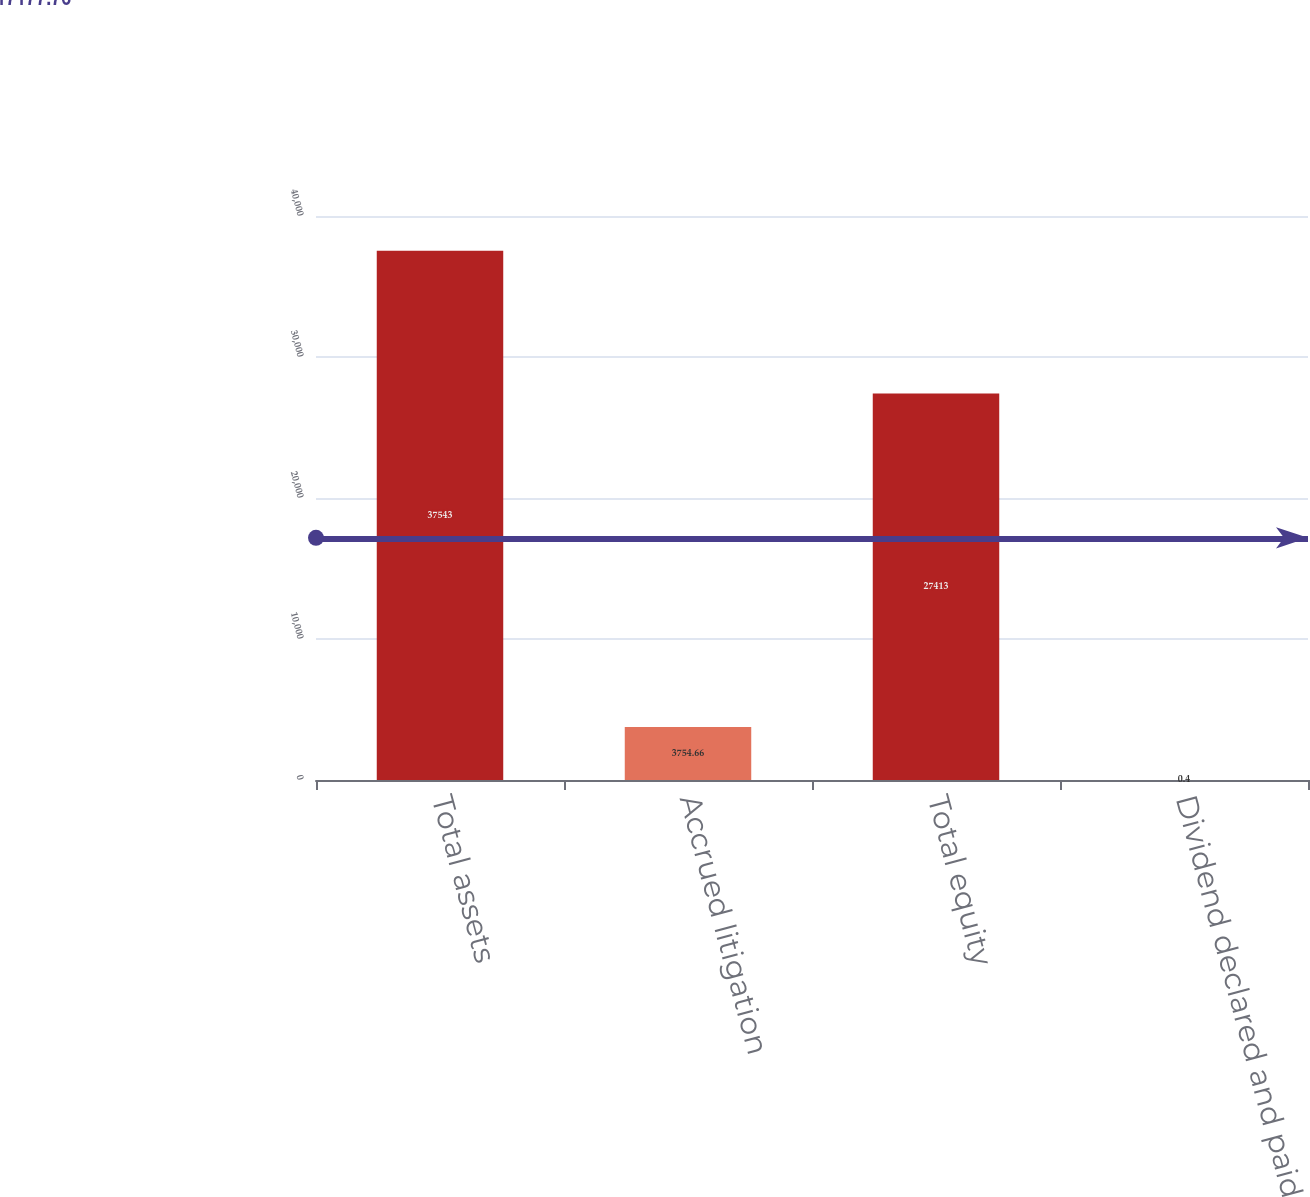Convert chart to OTSL. <chart><loc_0><loc_0><loc_500><loc_500><bar_chart><fcel>Total assets<fcel>Accrued litigation<fcel>Total equity<fcel>Dividend declared and paid per<nl><fcel>37543<fcel>3754.66<fcel>27413<fcel>0.4<nl></chart> 